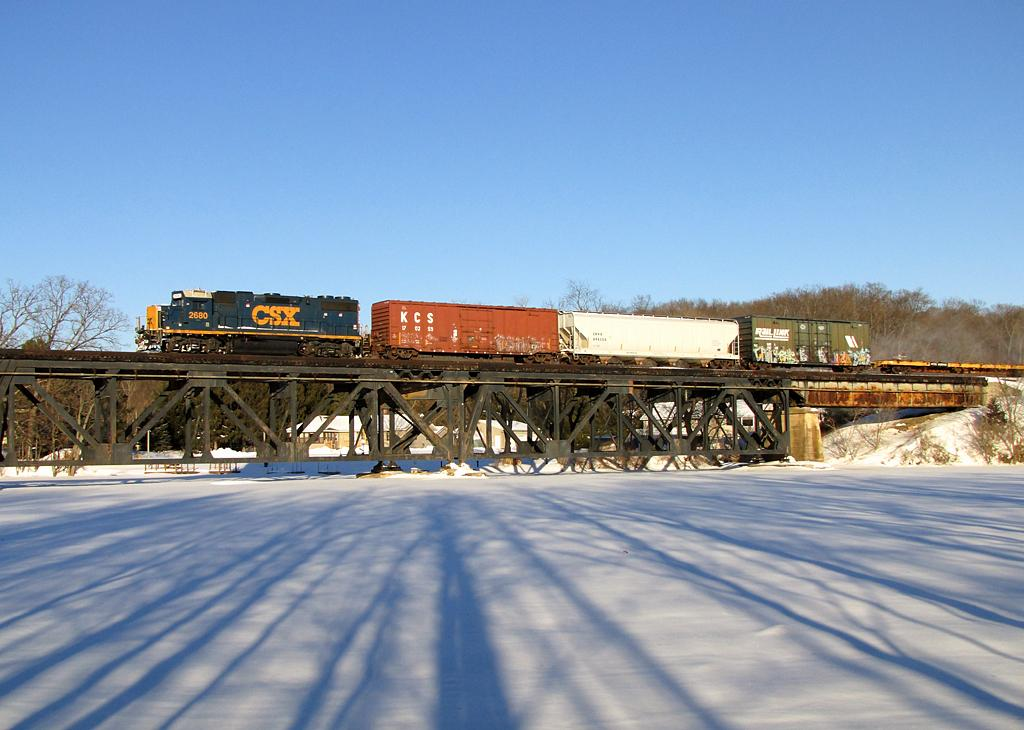<image>
Present a compact description of the photo's key features. A CSX train engine is pulling three cars across a trestle. 